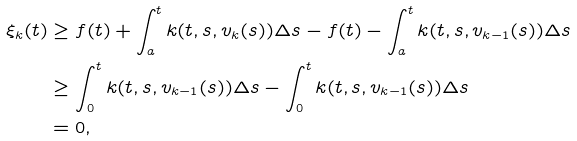<formula> <loc_0><loc_0><loc_500><loc_500>\xi _ { k } ( t ) & \geq f ( t ) + \int _ { a } ^ { t } k ( t , s , v _ { k } ( s ) ) \Delta s - f ( t ) - \int _ { a } ^ { t } k ( t , s , v _ { k - 1 } ( s ) ) \Delta s \\ & \geq \int _ { 0 } ^ { t } k ( t , s , v _ { k - 1 } ( s ) ) \Delta s - \int _ { 0 } ^ { t } k ( t , s , v _ { k - 1 } ( s ) ) \Delta s \\ & = 0 ,</formula> 